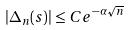Convert formula to latex. <formula><loc_0><loc_0><loc_500><loc_500>| \Delta _ { n } ( s ) | \leq C e ^ { - \alpha \sqrt { n } }</formula> 